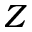<formula> <loc_0><loc_0><loc_500><loc_500>Z</formula> 